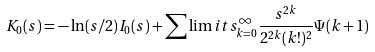Convert formula to latex. <formula><loc_0><loc_0><loc_500><loc_500>K _ { 0 } ( s ) = - \ln ( s / 2 ) I _ { 0 } ( s ) + \sum \lim i t s _ { k = 0 } ^ { \infty } \frac { s ^ { 2 k } } { 2 ^ { 2 k } ( k ! ) ^ { 2 } } \Psi ( k + 1 )</formula> 